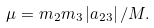<formula> <loc_0><loc_0><loc_500><loc_500>\mu = m _ { 2 } m _ { 3 } \left | a _ { 2 3 } \right | / M .</formula> 